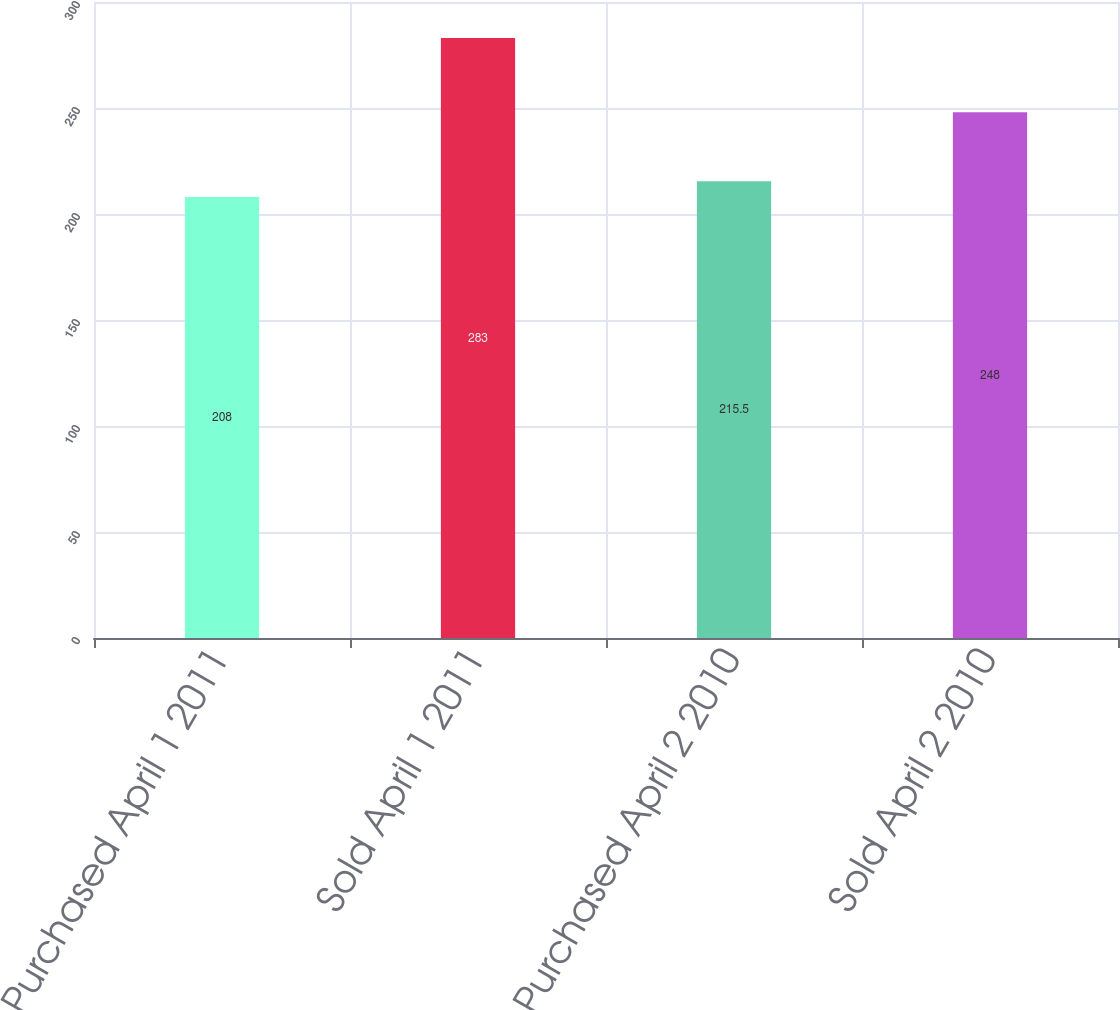<chart> <loc_0><loc_0><loc_500><loc_500><bar_chart><fcel>Purchased April 1 2011<fcel>Sold April 1 2011<fcel>Purchased April 2 2010<fcel>Sold April 2 2010<nl><fcel>208<fcel>283<fcel>215.5<fcel>248<nl></chart> 